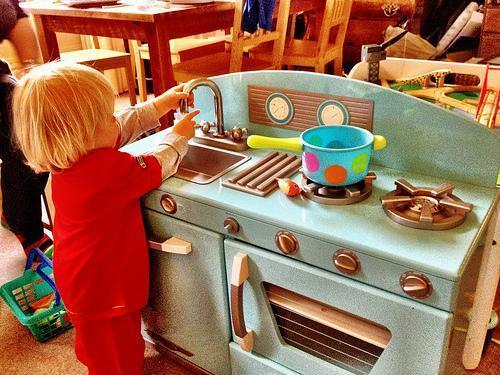How many children in picture?
Give a very brief answer. 1. How many doors are on the play kitchen set?
Give a very brief answer. 2. 